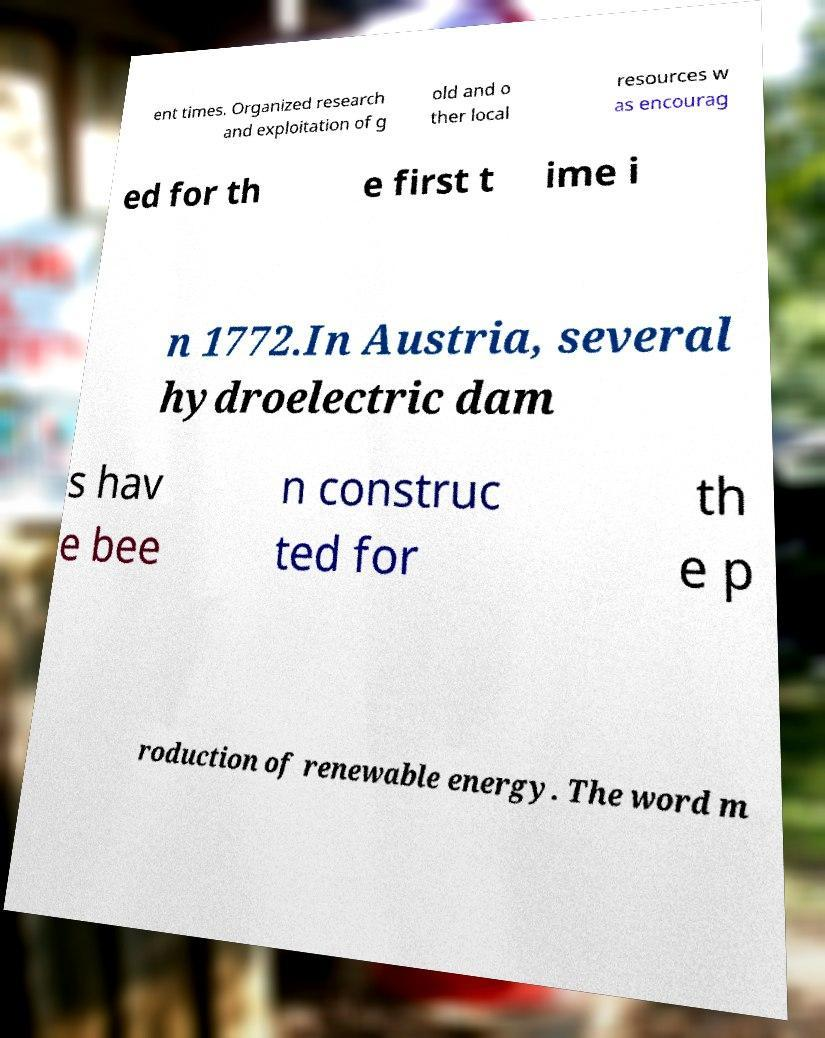I need the written content from this picture converted into text. Can you do that? ent times. Organized research and exploitation of g old and o ther local resources w as encourag ed for th e first t ime i n 1772.In Austria, several hydroelectric dam s hav e bee n construc ted for th e p roduction of renewable energy. The word m 